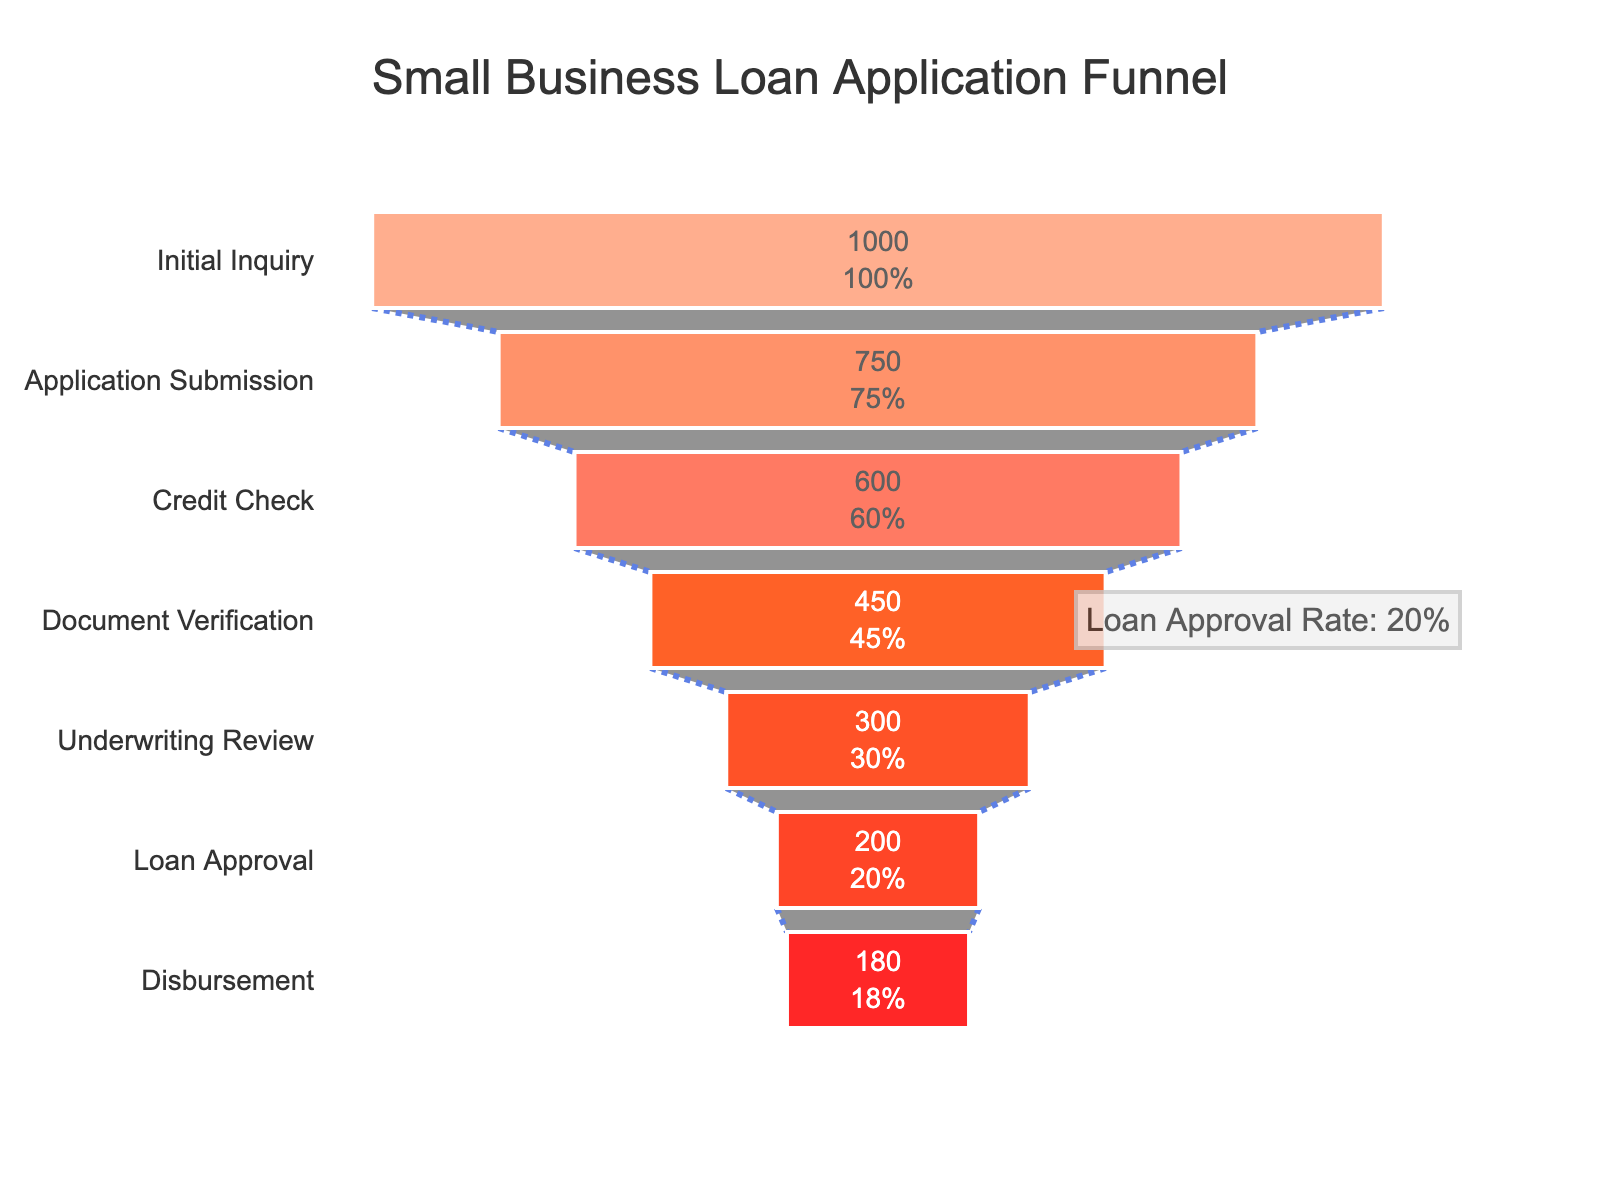What is the title of the funnel chart? The title is usually located at the top of the figure. In this case, it's clearly written above the funnel stages.
Answer: Small Business Loan Application Funnel How many applicants reached the 'Credit Check' stage? By looking at the funnel diagram, you can see the number of applicants at each stage. The 'Credit Check' stage has a corresponding number beneath it.
Answer: 600 Which stage shows the highest number of drop-offs in applicants? To find this, you need to look at the decrease in applicants from one stage to the next and identify the highest value. The difference between 'Application Submission' and 'Credit Check' stages is the greatest.
Answer: Application Submission to Credit Check What percentage of initial inquiries result in loan disbursement? Look at the 'Disbursement' stage and see its percentage relative to the 'Initial Inquiry' stage applicants. The chart provides this percentage directly.
Answer: 18% How many more applicants were there at the 'Initial Inquiry' stage compared to the 'Application Submission' stage? Subtract the number of applicants at 'Application Submission' from those at 'Initial Inquiry'. The difference is 1000 - 750.
Answer: 250 What is the loan approval rate indicated in the annotations? The loan approval rate is provided in a text annotation on the funnel chart. It is mentioned clearly there.
Answer: 20% Between which two stages do we see a drop of 150 applicants? Identify the stages with a difference of 150 applicants. 'Credit Check' has 600, and 'Document Verification' has 450, so the drop is 600 - 450.
Answer: Credit Check to Document Verification What is the color of the stage with the smallest number of applicants? Look at the color coding of the stages and identify the one with the smallest number, which is 'Disbursement'.
Answer: Red Is the decrease in applicants between each stage equal? The chart shows different numbers of applicants at each stage, so the decrease is not uniform. Verify this by looking at the difference in numbers between each pair of consecutive stages.
Answer: No What percentage of applicants pass the 'Underwriting Review' stage? The funnel chart shows the percentage of applicants at each stage relative to the initial number of applicants. Look at the percentage for 'Underwriting Review' stage.
Answer: 30% 